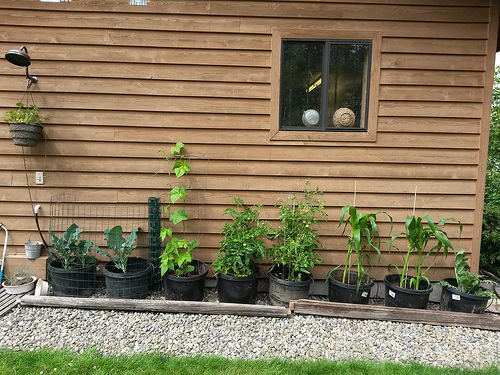<image>
Can you confirm if the plant is behind the window? No. The plant is not behind the window. From this viewpoint, the plant appears to be positioned elsewhere in the scene. Where is the plant in relation to the pot? Is it in the pot? No. The plant is not contained within the pot. These objects have a different spatial relationship. 